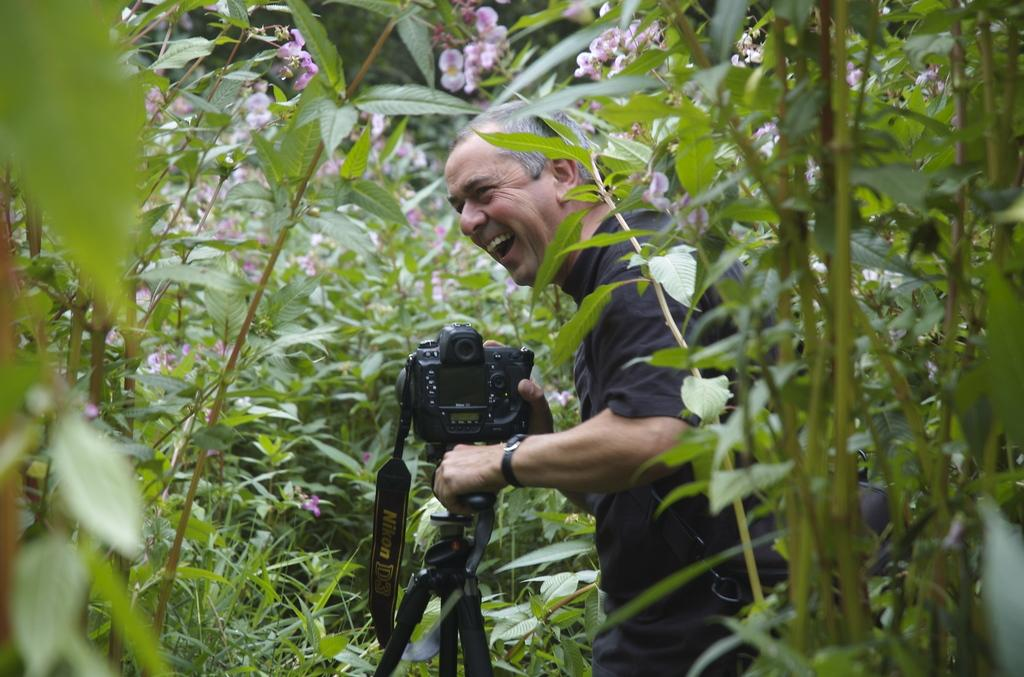What is the main subject of the picture? The main subject of the picture is a man. What is the man doing in the picture? The man is standing and laughing in the picture. What is the man holding in his hands? The man is holding a camera in his hands. What can be seen in the background or vicinity of the man? There are trees and plants in the vicinity of the man. How many brothers does the man have in the image? There is no information about the man's brothers in the image. 